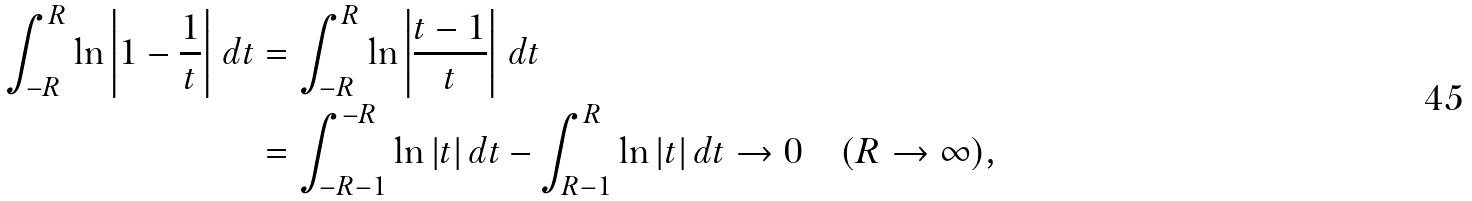<formula> <loc_0><loc_0><loc_500><loc_500>\int _ { - R } ^ { R } \ln \left | 1 - \frac { 1 } { t } \right | \, d t & = \int _ { - R } ^ { R } \ln \left | \frac { t - 1 } { t } \right | \, d t \\ & = \int _ { - R - 1 } ^ { - R } \ln | t | \, d t - \int _ { R - 1 } ^ { R } \ln | t | \, d t \to 0 \quad ( R \to \infty ) ,</formula> 